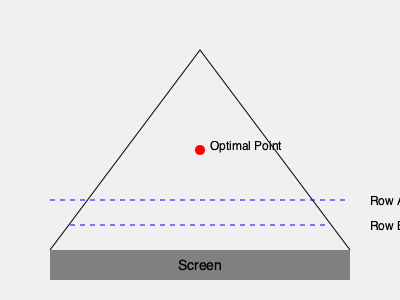Given the theater layout shown, where the screen is 300 units wide and the optimal viewing distance is 200 units from the screen center, determine the maximum number of seats that can be placed in Row A if each seat requires a minimum viewing angle of 30 degrees and a width of 20 units. To solve this problem, we'll follow these steps:

1) First, we need to calculate the total viewing angle for Row A:
   - The distance from the screen to Row A is 200 units
   - The screen width is 300 units
   - Using the arctangent function: $\theta = 2 \times \tan^{-1}(\frac{300/2}{200})$
   - $\theta = 2 \times \tan^{-1}(0.75) \approx 73.74$ degrees

2) Now, we need to determine how many 30-degree segments can fit within this angle:
   - Number of segments = $73.74 \div 30 \approx 2.458$
   - We can fit 2 full 30-degree segments

3) However, we also need to consider the physical width of the seats:
   - The arc length of Row A = $2\pi r \times \frac{\theta}{360°}$, where $r = 200$ units
   - Arc length = $2\pi \times 200 \times \frac{73.74}{360} \approx 257.15$ units

4) Given that each seat requires 20 units of width:
   - Maximum number of seats = $257.15 \div 20 \approx 12.86$

5) We need to take the smaller of the two constraints:
   - Angle constraint: 2 seats
   - Width constraint: 12 seats

Therefore, the maximum number of seats that can be placed in Row A while maintaining the minimum viewing angle is 2.
Answer: 2 seats 